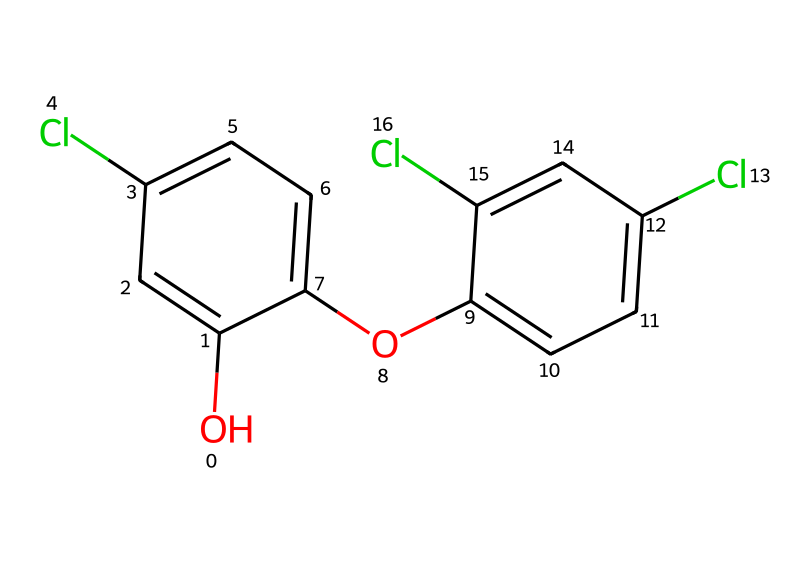What is the molecular formula for triclosan? To derive the molecular formula from the SMILES representation, we can count the types of atoms present. In the provided SMILES: 12 carbon atoms (c), 8 hydrogen atoms (H), 4 chlorine atoms (Cl), and 2 oxygen atoms (O) can be identified. Compiling these gives C12H8Cl4O2.
Answer: C12H8Cl4O2 How many chlorine atoms are present in triclosan? Looking into the SMILES representation, we can identify each occurrence of the chlorine symbol "Cl". There are four instances of "Cl" in the structure. Therefore, the molecule contains four chlorine atoms.
Answer: 4 What type of functional groups are found in triclosan? From the SMILES, we can see "O" representing hydroxyl groups (-OH) and ether groups present in the structure as indicated by the presence of two "O" links in the aromatic system. Thus, triclosan contains hydroxyl and ether functional groups.
Answer: hydroxyl and ether Which part of the structure contributes to triclosan's antibacterial properties? The presence of chlorinated phenolic groups typically contributes to the antibacterial activity in such compounds. In the provided SMILES, the multiple chlorine atoms attached to the phenolic rings indicate that these areas are important for its antibacterial properties.
Answer: chlorinated phenolic groups What is the significance of the aromatic rings in triclosan? The aromatic rings provide a stable framework that influences the solubility and overall chemical behavior of triclosan. They are also critical for interaction with biological targets, enhancing the ability of triclosan to bind to specific sites within bacteria.
Answer: stability and binding ability How many carbon rings can be identified in the structure of triclosan? By examining the SMILES closely, we can see that there are two distinct benzene rings present in the structure. Each ring is represented by clusters of "c" letters grouped together in the SMILES.
Answer: 2 